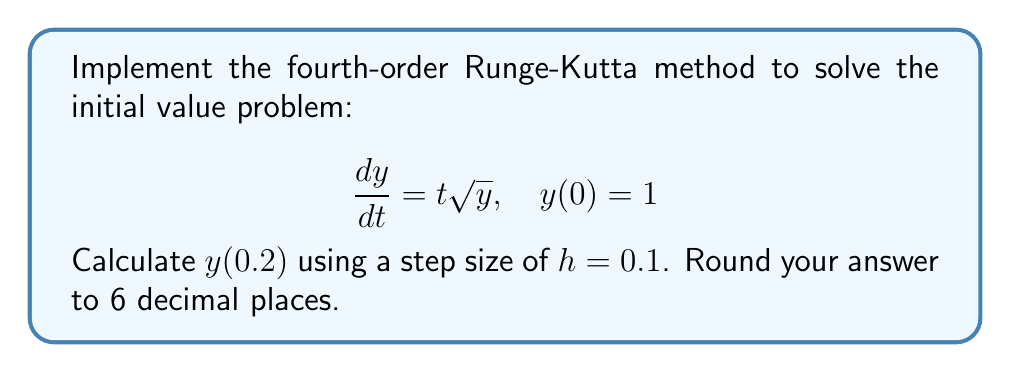Show me your answer to this math problem. The fourth-order Runge-Kutta method for solving ODEs is given by:

$$y_{n+1} = y_n + \frac{1}{6}(k_1 + 2k_2 + 2k_3 + k_4)$$

Where:
$$\begin{align*}
k_1 &= hf(t_n, y_n) \\
k_2 &= hf(t_n + \frac{h}{2}, y_n + \frac{k_1}{2}) \\
k_3 &= hf(t_n + \frac{h}{2}, y_n + \frac{k_2}{2}) \\
k_4 &= hf(t_n + h, y_n + k_3)
\end{align*}$$

For our problem, $f(t, y) = t\sqrt{y}$.

Step 1: Calculate $y(0.1)$
$t_0 = 0$, $y_0 = 1$, $h = 0.1$

$$\begin{align*}
k_1 &= 0.1 \cdot 0 \cdot \sqrt{1} = 0 \\
k_2 &= 0.1 \cdot (0.05) \cdot \sqrt{1 + 0/2} = 0.005 \\
k_3 &= 0.1 \cdot (0.05) \cdot \sqrt{1 + 0.005/2} \approx 0.005000625 \\
k_4 &= 0.1 \cdot (0.1) \cdot \sqrt{1 + 0.005000625} \approx 0.010025031
\end{align*}$$

$$y_1 = 1 + \frac{1}{6}(0 + 2(0.005) + 2(0.005000625) + 0.010025031) \approx 1.005004271$$

Step 2: Calculate $y(0.2)$
$t_1 = 0.1$, $y_1 = 1.005004271$, $h = 0.1$

$$\begin{align*}
k_1 &= 0.1 \cdot 0.1 \cdot \sqrt{1.005004271} \approx 0.010025021 \\
k_2 &= 0.1 \cdot 0.15 \cdot \sqrt{1.005004271 + 0.010025021/2} \approx 0.015054658 \\
k_3 &= 0.1 \cdot 0.15 \cdot \sqrt{1.005004271 + 0.015054658/2} \approx 0.015061840 \\
k_4 &= 0.1 \cdot 0.2 \cdot \sqrt{1.005004271 + 0.015061840} \approx 0.020165479
\end{align*}$$

$$y_2 = 1.005004271 + \frac{1}{6}(0.010025021 + 2(0.015054658) + 2(0.015061840) + 0.020165479) \approx 1.015075125$$

Therefore, $y(0.2) \approx 1.015075$.
Answer: 1.015075 